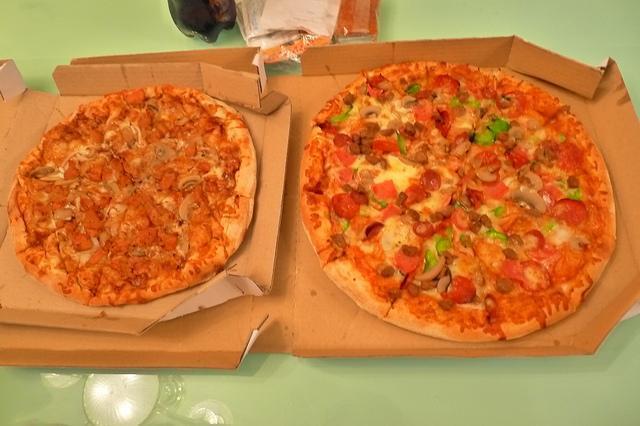How many pizzas can be seen?
Give a very brief answer. 2. 